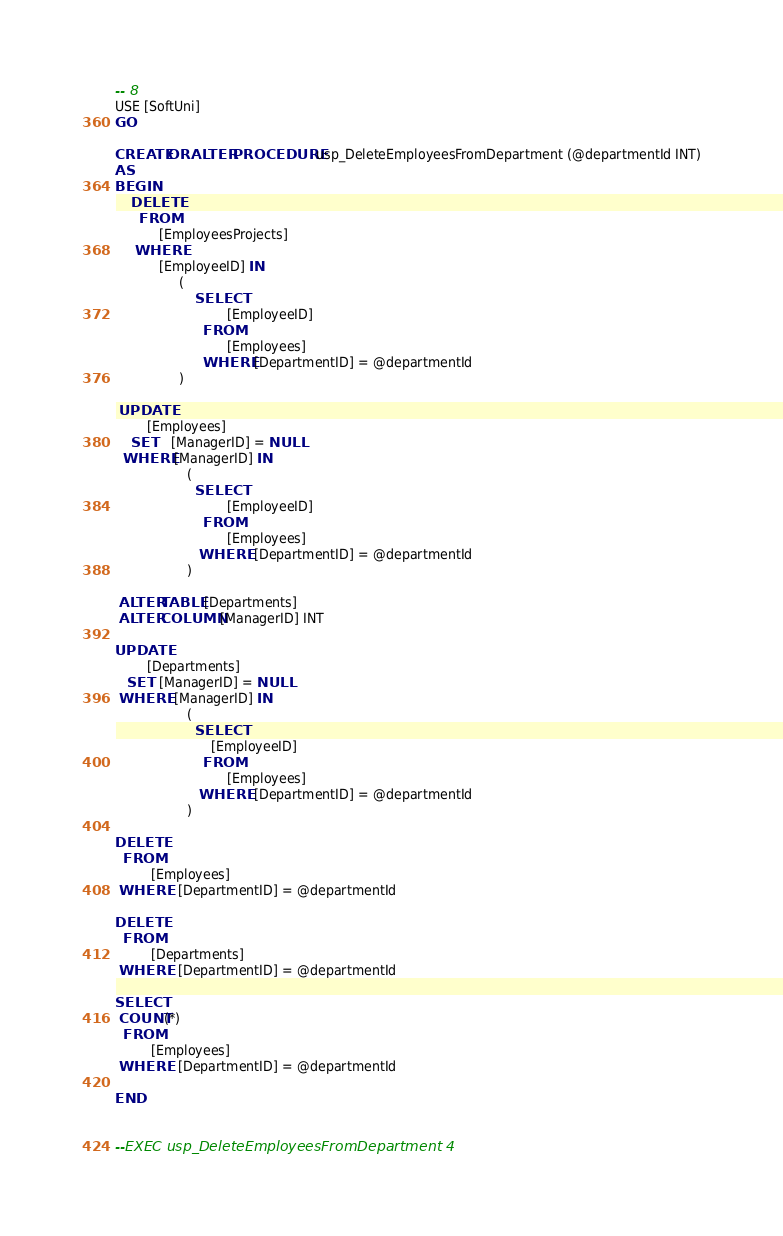<code> <loc_0><loc_0><loc_500><loc_500><_SQL_>-- 8
USE [SoftUni]
GO

CREATE OR ALTER PROCEDURE usp_DeleteEmployeesFromDepartment (@departmentId INT)
AS
BEGIN
	DELETE
      FROM
		   [EmployeesProjects]
     WHERE 
		   [EmployeeID] IN 
				(
					SELECT
							[EmployeeID]
					  FROM
							[Employees]
					  WHERE [DepartmentID] = @departmentId
				)

 UPDATE 
		[Employees]
    SET	[ManagerID] = NULL
  WHERE [ManagerID] IN 
				  (
					SELECT
							[EmployeeID]
					  FROM
							[Employees]
					 WHERE  [DepartmentID] = @departmentId     
				  )

 ALTER TABLE [Departments]
 ALTER COLUMN [ManagerID] INT

UPDATE 
		[Departments]
   SET  [ManagerID] = NULL
 WHERE  [ManagerID] IN 
				  (
					SELECT
						[EmployeeID]
					  FROM
							[Employees]
					 WHERE  [DepartmentID] = @departmentId					        
				  )

DELETE 
  FROM
	     [Employees]
 WHERE   [DepartmentID] = @departmentId

DELETE 
  FROM
	     [Departments]
 WHERE   [DepartmentID] = @departmentId

SELECT 
 COUNT(*)
  FROM
		 [Employees]
 WHERE   [DepartmentID] = @departmentId

END


--EXEC usp_DeleteEmployeesFromDepartment 4



</code> 